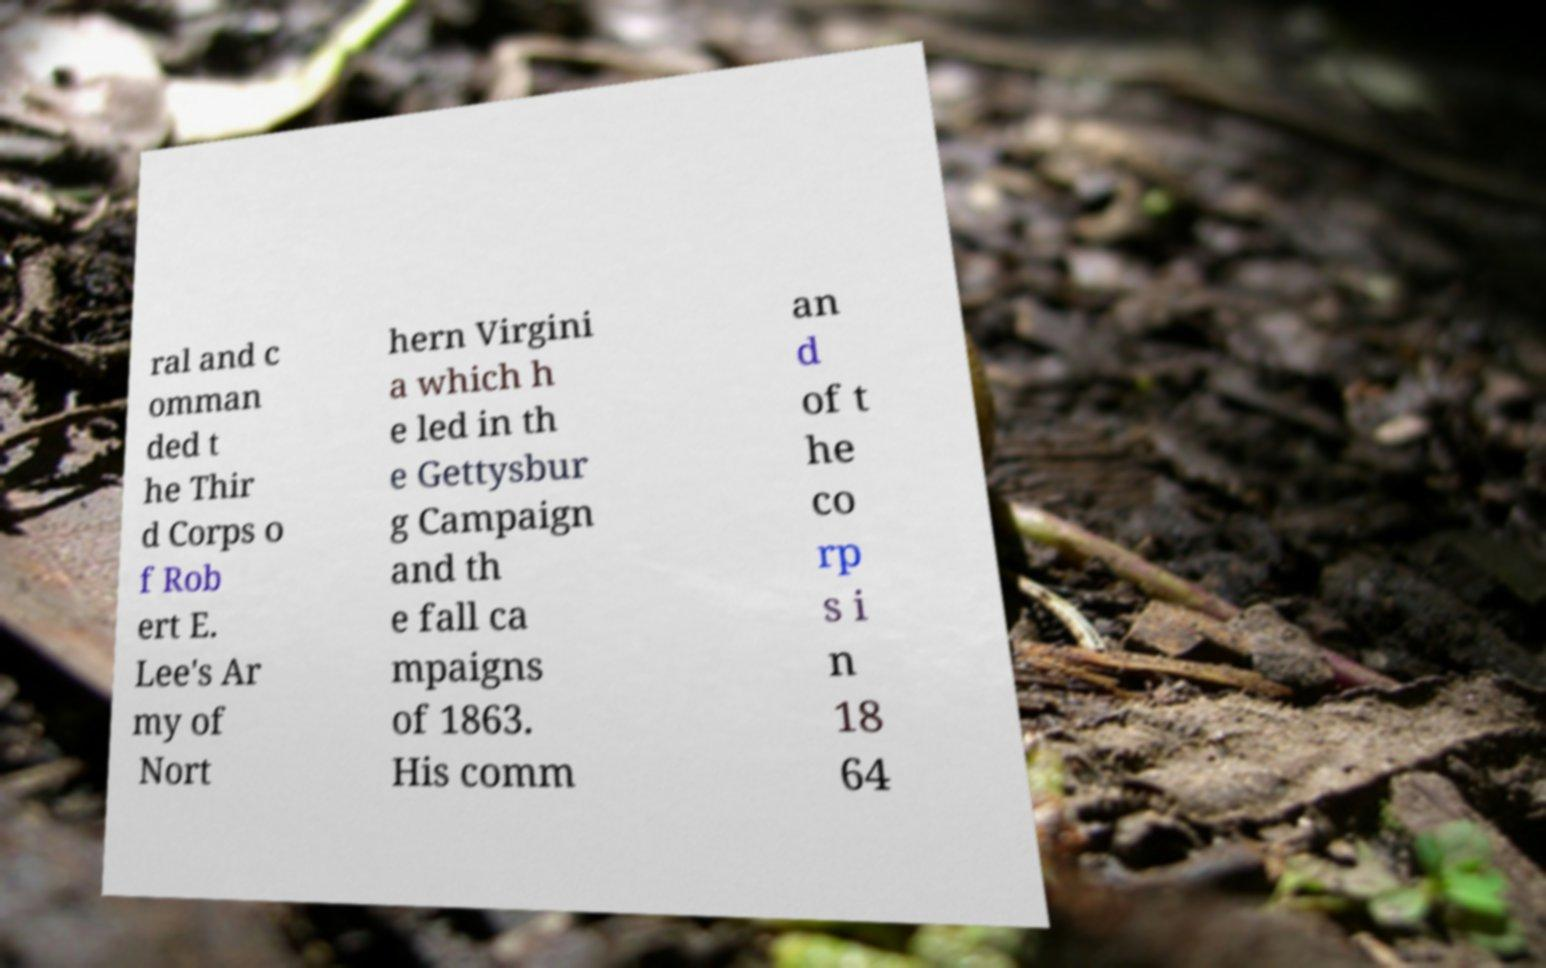What messages or text are displayed in this image? I need them in a readable, typed format. ral and c omman ded t he Thir d Corps o f Rob ert E. Lee's Ar my of Nort hern Virgini a which h e led in th e Gettysbur g Campaign and th e fall ca mpaigns of 1863. His comm an d of t he co rp s i n 18 64 